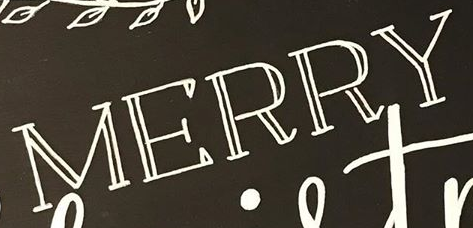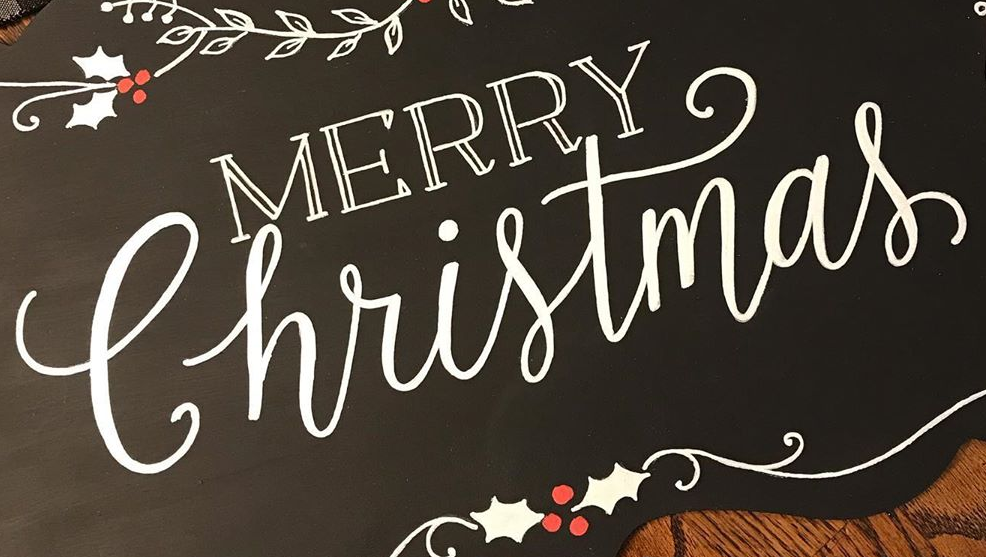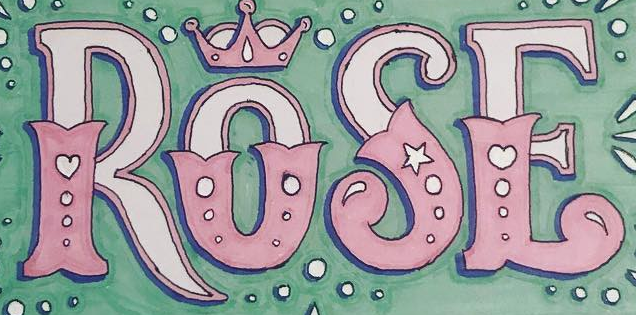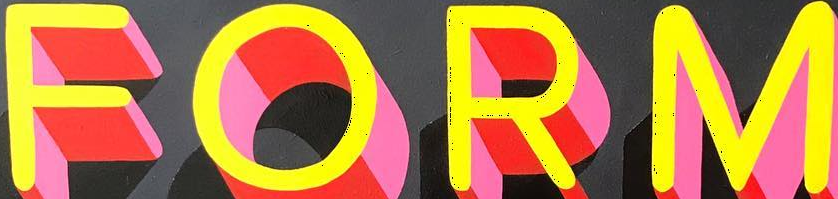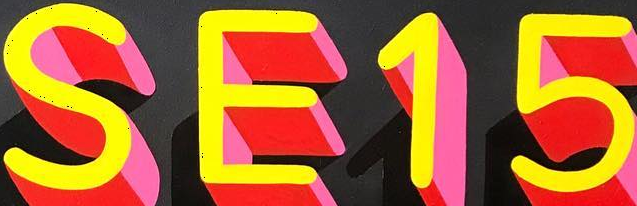Read the text from these images in sequence, separated by a semicolon. MERRY; Christmas; ROSE; FORM; SE15 